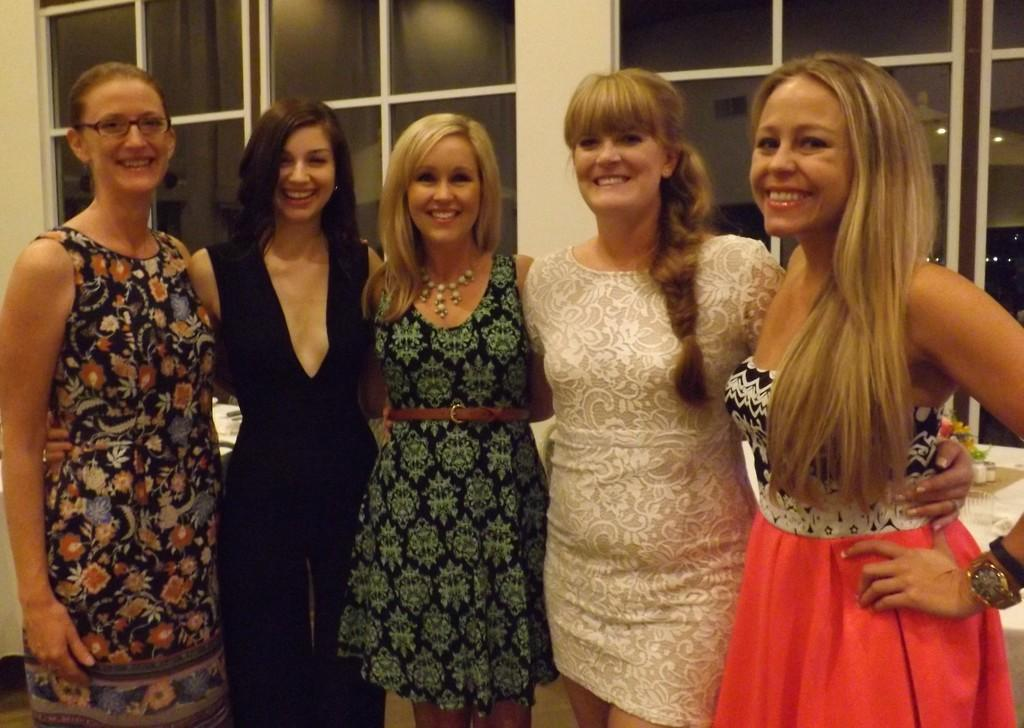Who or what can be seen in the image? There are people in the image. What are the people doing in the image? The people are smiling in the image. Where are the people standing in the image? The people are standing on a surface in the image. What can be seen in the background of the image? There are glass windows in the background of the image. What type of noise can be heard coming from the minister in the image? There is no minister present in the image, so it's not possible to determine what, if any, noise might be heard. 